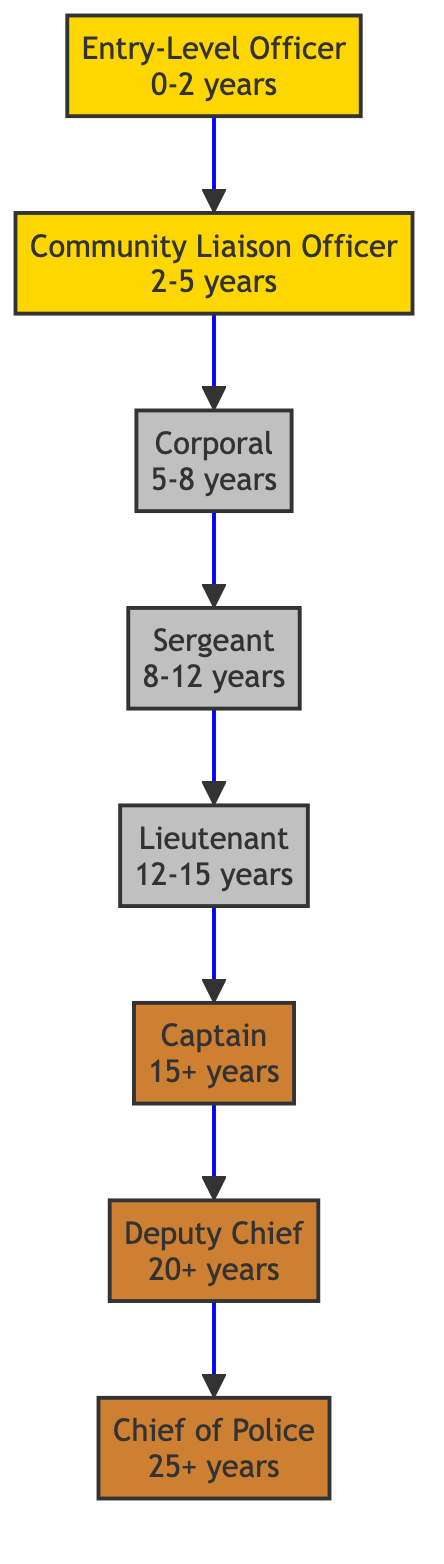What is the first level in the career progression? The diagram indicates that the first level is "Entry-Level Officer," which is the position at the bottom of the flowchart.
Answer: Entry-Level Officer How many years of experience is required for the Corporal position? The flowchart shows that the Corporal position requires 5-8 years of experience, which can be determined by checking the level above Entry.
Answer: 5-8 years What is the title at Level 4? The title at Level 4 can be found by identifying the node that corresponds to that level in the diagram, which is "Sergeant."
Answer: Sergeant What is the highest position in community policing according to the diagram? The diagram depicts "Chief of Police" as the highest position, which is located at the top of the flowchart.
Answer: Chief of Police Which position oversees community policing policy? To answer this, we look for the role that focuses on community policing policy, which is the "Deputy Chief." The responsibilities indicate this role supervises related policies.
Answer: Deputy Chief What level comes before Captain? By following the flow of the diagram upwards from Captain, we identify that the position directly below it is "Lieutenant."
Answer: Lieutenant How many levels are there in total in this diagram? We can count the nodes in the diagram, starting from Entry-Level Officer at the bottom up to the Chief of Police at the top; there are a total of 8 levels.
Answer: 8 Which position requires a Master's in Criminology? The flowchart specifies that the "Captain" position requires a Master's in Criminology as part of its training, indicated under that node.
Answer: Captain What is the minimum experience required to become a Lieutenant? Looking at the flowchart, the experience needed for Lieutenant is 12-15 years, which is information directly stated next to that level.
Answer: 12-15 years 